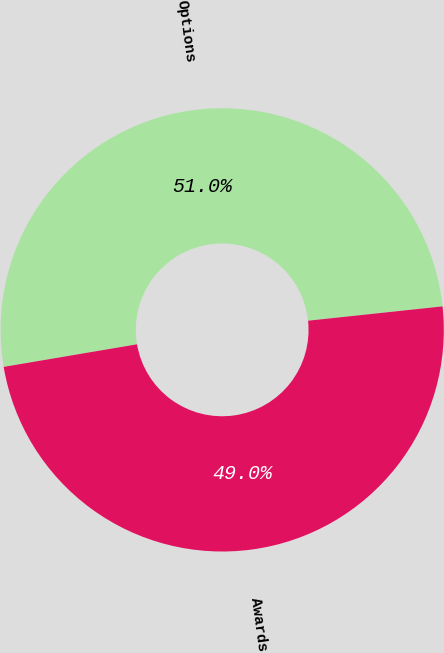Convert chart to OTSL. <chart><loc_0><loc_0><loc_500><loc_500><pie_chart><fcel>Options<fcel>Awards<nl><fcel>50.98%<fcel>49.02%<nl></chart> 